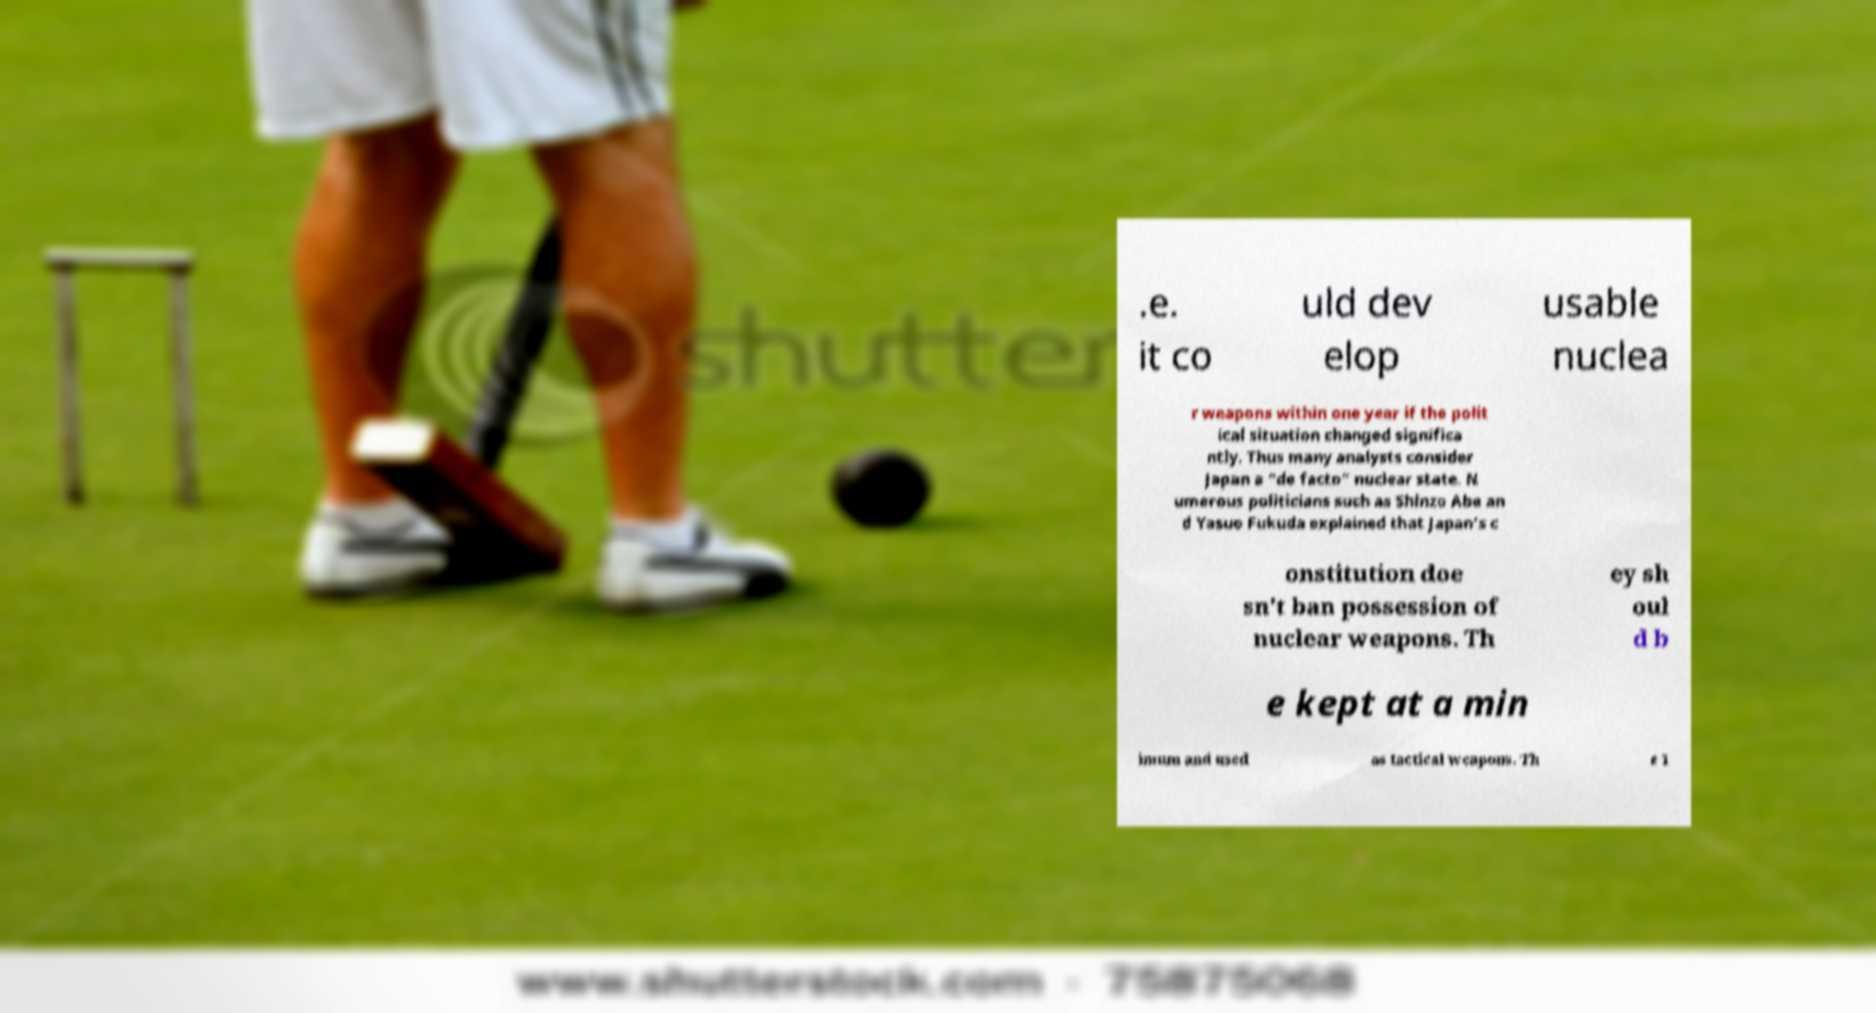Can you accurately transcribe the text from the provided image for me? .e. it co uld dev elop usable nuclea r weapons within one year if the polit ical situation changed significa ntly. Thus many analysts consider Japan a "de facto" nuclear state. N umerous politicians such as Shinzo Abe an d Yasuo Fukuda explained that Japan's c onstitution doe sn't ban possession of nuclear weapons. Th ey sh oul d b e kept at a min imum and used as tactical weapons. Th e 1 